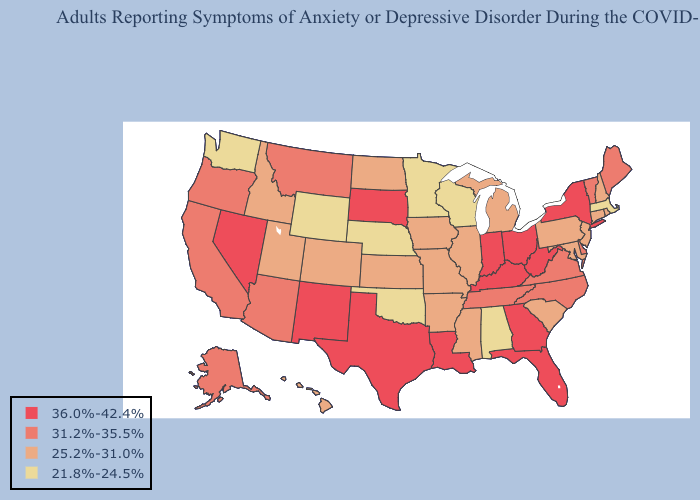Among the states that border Tennessee , does Arkansas have the lowest value?
Answer briefly. No. Name the states that have a value in the range 25.2%-31.0%?
Short answer required. Arkansas, Colorado, Connecticut, Hawaii, Idaho, Illinois, Iowa, Kansas, Maryland, Michigan, Mississippi, Missouri, New Hampshire, New Jersey, North Dakota, Pennsylvania, Rhode Island, South Carolina, Utah. Does California have the lowest value in the West?
Be succinct. No. Name the states that have a value in the range 25.2%-31.0%?
Keep it brief. Arkansas, Colorado, Connecticut, Hawaii, Idaho, Illinois, Iowa, Kansas, Maryland, Michigan, Mississippi, Missouri, New Hampshire, New Jersey, North Dakota, Pennsylvania, Rhode Island, South Carolina, Utah. Name the states that have a value in the range 25.2%-31.0%?
Short answer required. Arkansas, Colorado, Connecticut, Hawaii, Idaho, Illinois, Iowa, Kansas, Maryland, Michigan, Mississippi, Missouri, New Hampshire, New Jersey, North Dakota, Pennsylvania, Rhode Island, South Carolina, Utah. Among the states that border Arizona , does Colorado have the highest value?
Quick response, please. No. Does North Carolina have the same value as Tennessee?
Write a very short answer. Yes. Among the states that border North Dakota , which have the highest value?
Keep it brief. South Dakota. Which states hav the highest value in the MidWest?
Answer briefly. Indiana, Ohio, South Dakota. What is the highest value in states that border Texas?
Answer briefly. 36.0%-42.4%. Name the states that have a value in the range 25.2%-31.0%?
Answer briefly. Arkansas, Colorado, Connecticut, Hawaii, Idaho, Illinois, Iowa, Kansas, Maryland, Michigan, Mississippi, Missouri, New Hampshire, New Jersey, North Dakota, Pennsylvania, Rhode Island, South Carolina, Utah. What is the value of Rhode Island?
Answer briefly. 25.2%-31.0%. Does Idaho have a higher value than Oklahoma?
Answer briefly. Yes. How many symbols are there in the legend?
Write a very short answer. 4. What is the lowest value in the USA?
Be succinct. 21.8%-24.5%. 